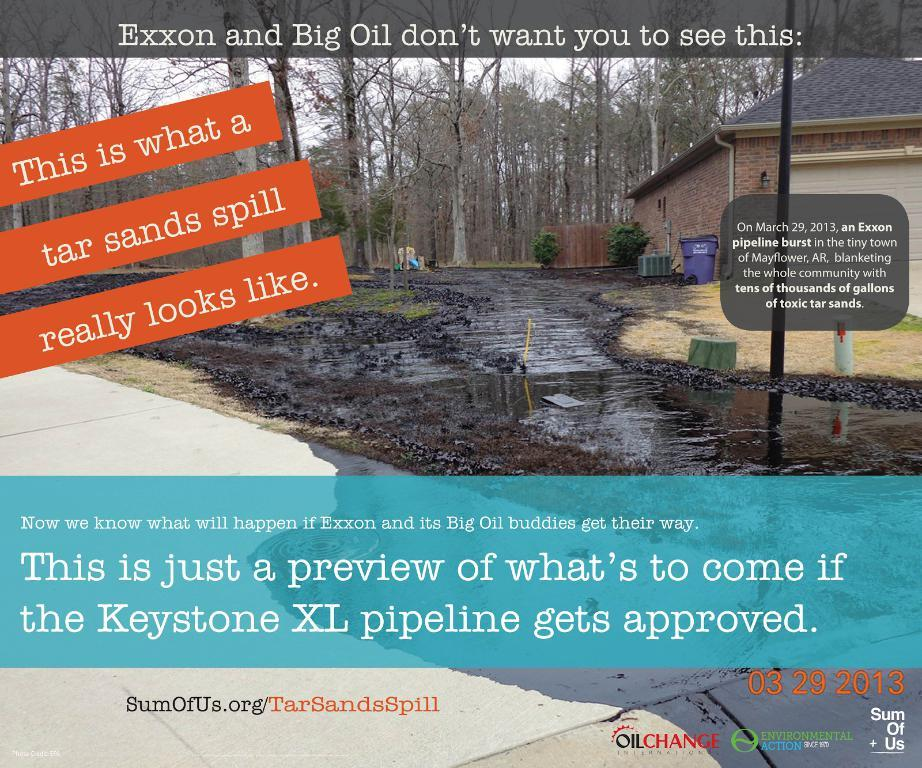What is featured on the poster in the image? There is a poster in the image, and it has text on it. What type of vegetation can be seen in the image? There are trees in the image. What type of structure is visible in the image? There is a building in the image. What item is present for disposing of waste in the image? There is a waste bin in the image. Can you describe the baseball scene depicted on the poster? There is no baseball scene present on the poster; it only has text on it. 